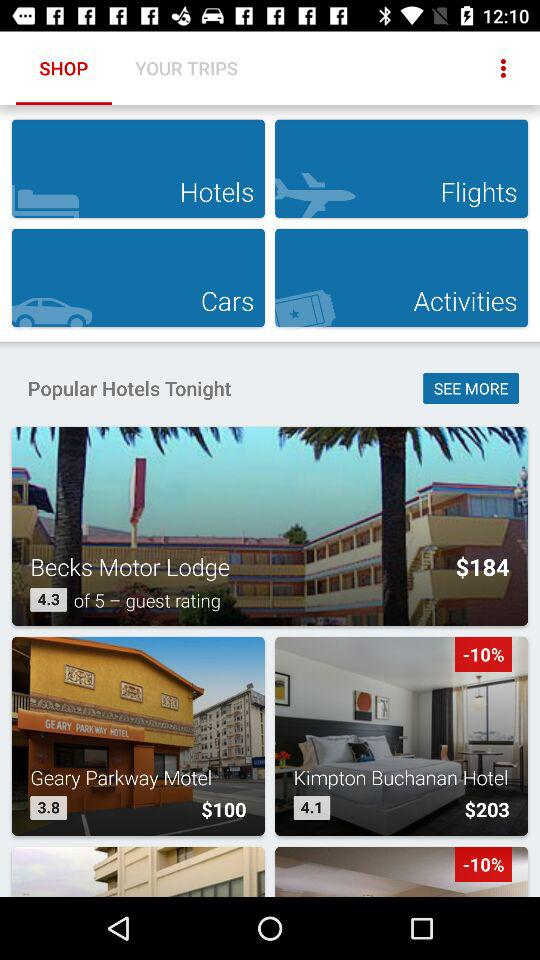What is the rating given by guests for "Geary Parkway Motel"? The rating given by guests for "Geary Parkway Motel" is 3.8. 